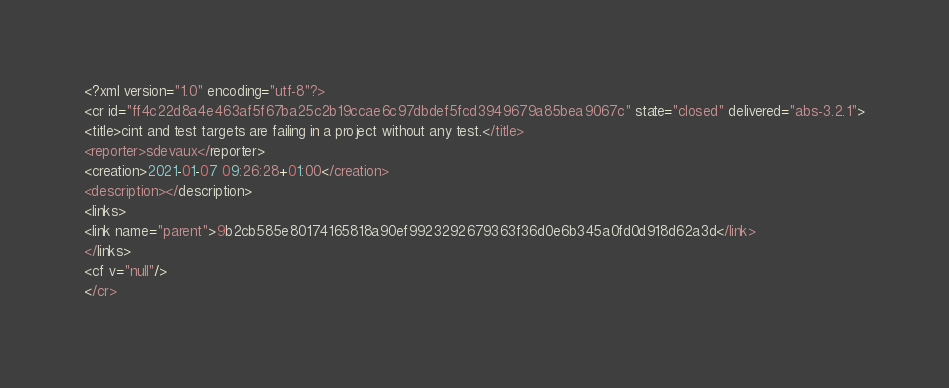Convert code to text. <code><loc_0><loc_0><loc_500><loc_500><_Crystal_><?xml version="1.0" encoding="utf-8"?>
<cr id="ff4c22d8a4e463af5f67ba25c2b19ccae6c97dbdef5fcd3949679a85bea9067c" state="closed" delivered="abs-3.2.1">
<title>cint and test targets are failing in a project without any test.</title>
<reporter>sdevaux</reporter>
<creation>2021-01-07 09:26:28+01:00</creation>
<description></description>
<links>
<link name="parent">9b2cb585e80174165818a90ef9923292679363f36d0e6b345a0fd0d918d62a3d</link>
</links>
<cf v="null"/>
</cr>
</code> 